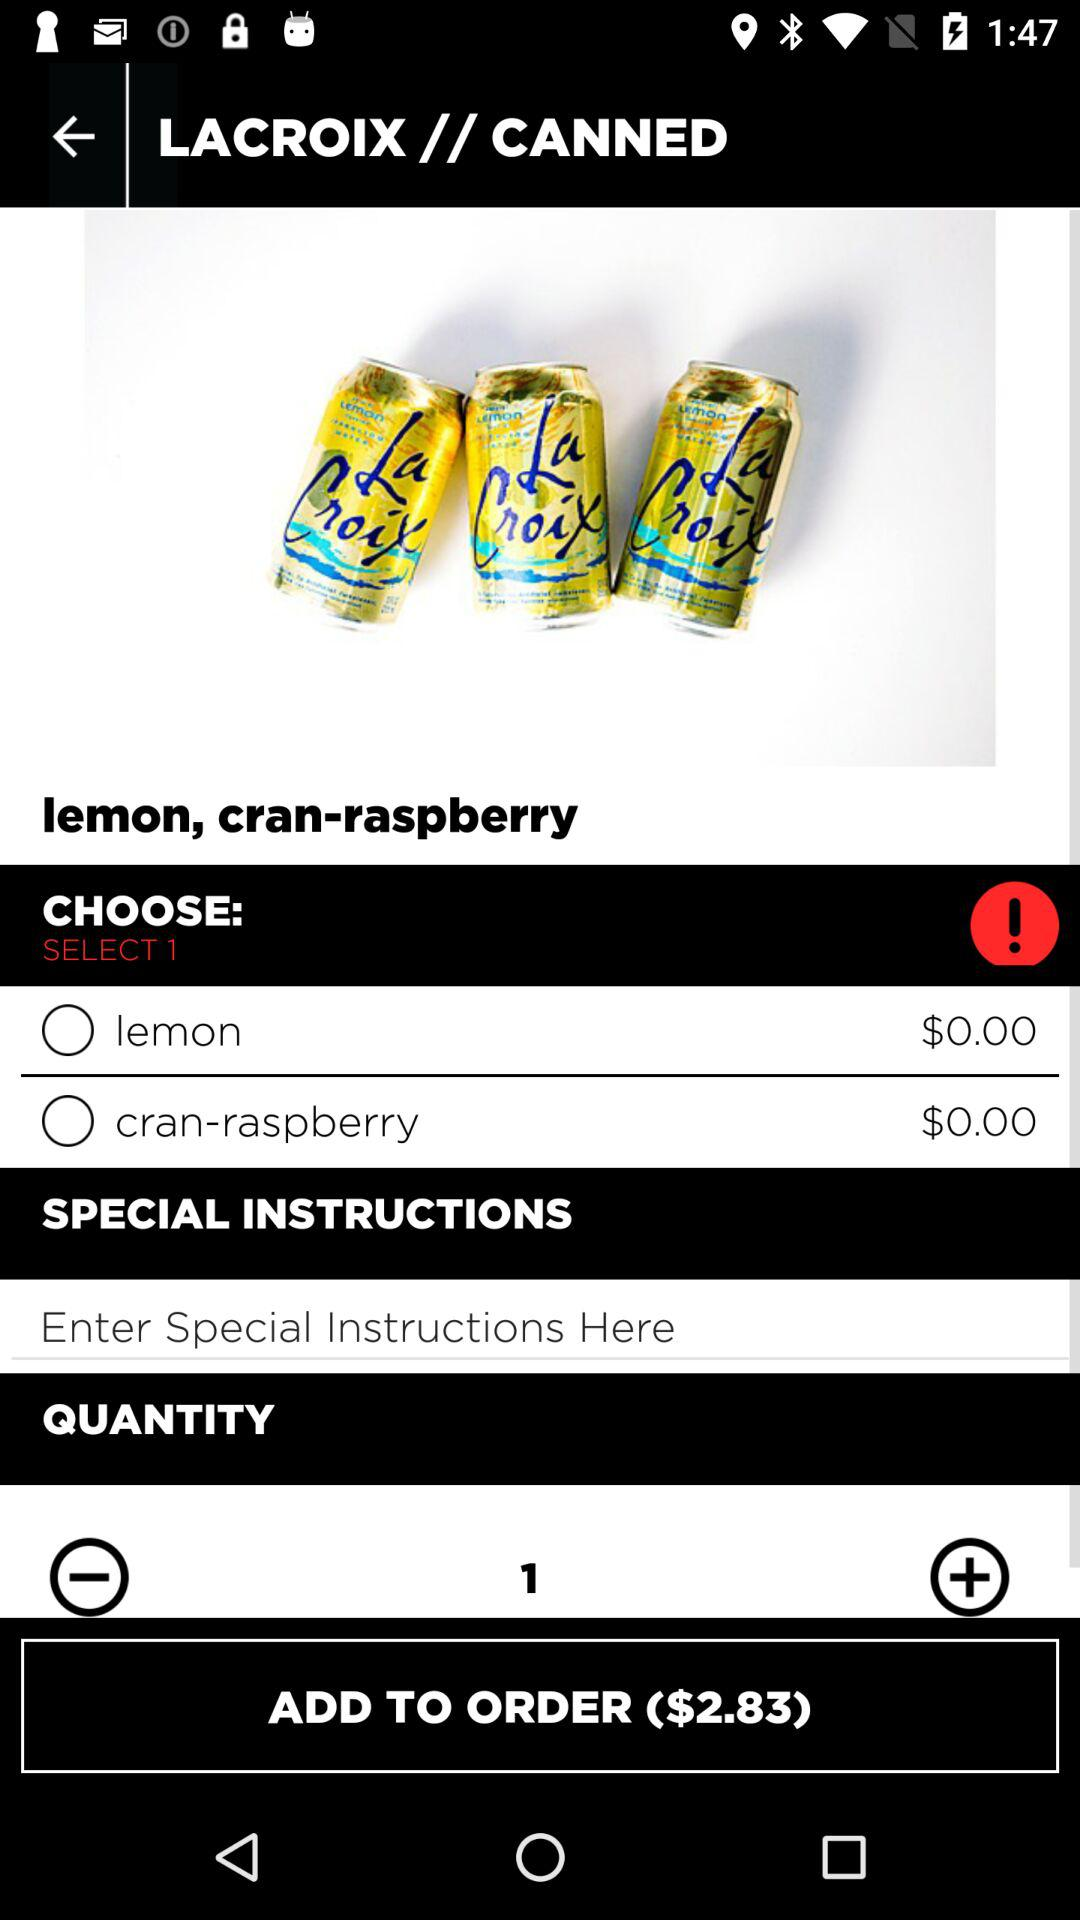How much does the "cran-raspberry" cost? The "cran-raspberry" costs $0. 